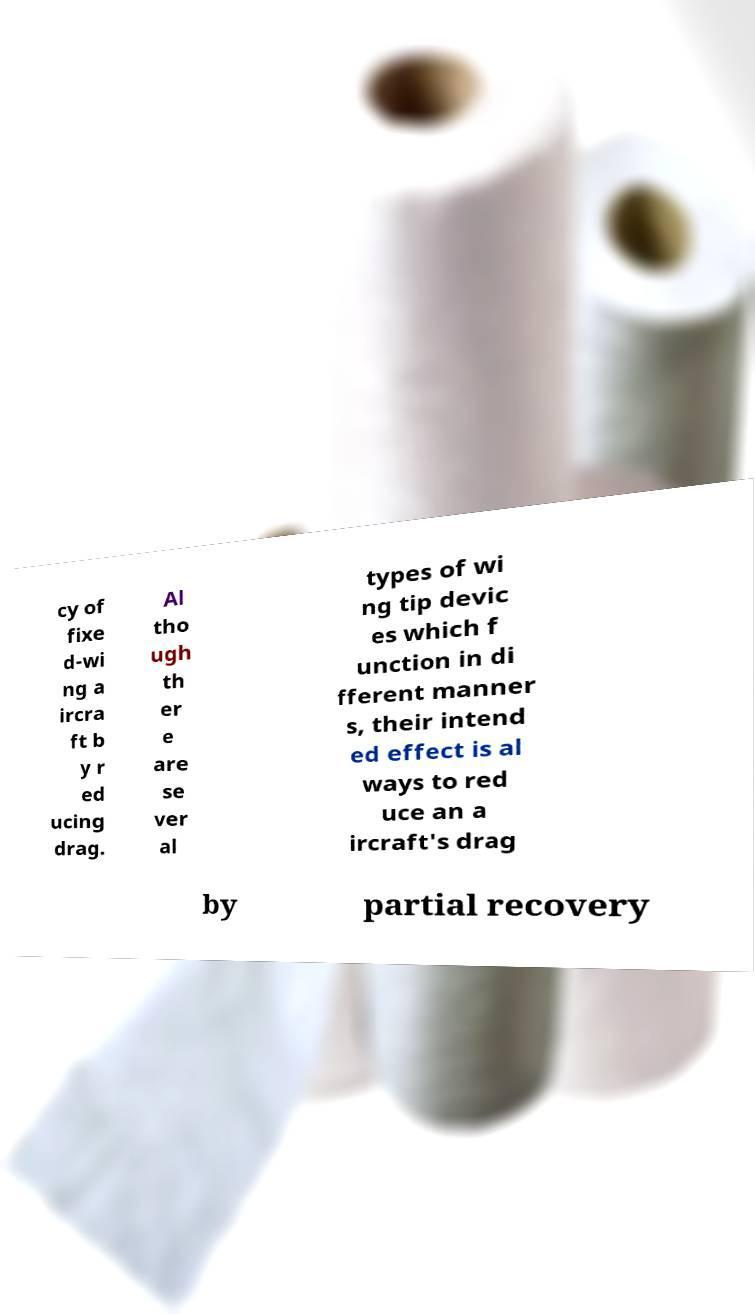I need the written content from this picture converted into text. Can you do that? cy of fixe d-wi ng a ircra ft b y r ed ucing drag. Al tho ugh th er e are se ver al types of wi ng tip devic es which f unction in di fferent manner s, their intend ed effect is al ways to red uce an a ircraft's drag by partial recovery 